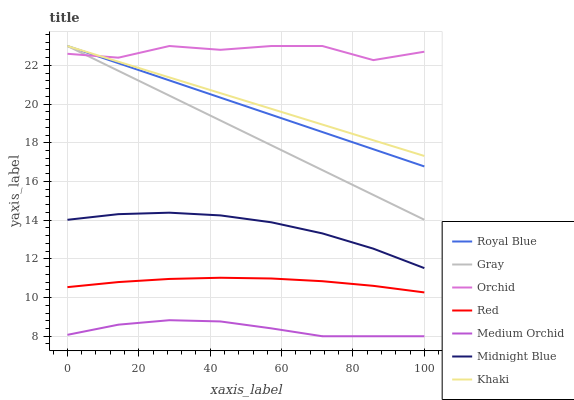Does Medium Orchid have the minimum area under the curve?
Answer yes or no. Yes. Does Orchid have the maximum area under the curve?
Answer yes or no. Yes. Does Khaki have the minimum area under the curve?
Answer yes or no. No. Does Khaki have the maximum area under the curve?
Answer yes or no. No. Is Royal Blue the smoothest?
Answer yes or no. Yes. Is Orchid the roughest?
Answer yes or no. Yes. Is Khaki the smoothest?
Answer yes or no. No. Is Khaki the roughest?
Answer yes or no. No. Does Medium Orchid have the lowest value?
Answer yes or no. Yes. Does Khaki have the lowest value?
Answer yes or no. No. Does Orchid have the highest value?
Answer yes or no. Yes. Does Midnight Blue have the highest value?
Answer yes or no. No. Is Medium Orchid less than Orchid?
Answer yes or no. Yes. Is Royal Blue greater than Medium Orchid?
Answer yes or no. Yes. Does Khaki intersect Gray?
Answer yes or no. Yes. Is Khaki less than Gray?
Answer yes or no. No. Is Khaki greater than Gray?
Answer yes or no. No. Does Medium Orchid intersect Orchid?
Answer yes or no. No. 